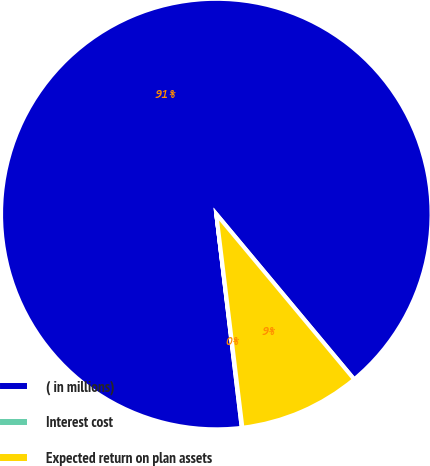Convert chart. <chart><loc_0><loc_0><loc_500><loc_500><pie_chart><fcel>( in millions)<fcel>Interest cost<fcel>Expected return on plan assets<nl><fcel>90.82%<fcel>0.05%<fcel>9.13%<nl></chart> 